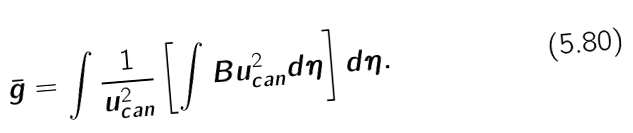<formula> <loc_0><loc_0><loc_500><loc_500>\bar { g } = \int \frac { 1 } { u ^ { 2 } _ { c a n } } \left [ \int B u ^ { 2 } _ { c a n } d \eta \right ] d \eta .</formula> 